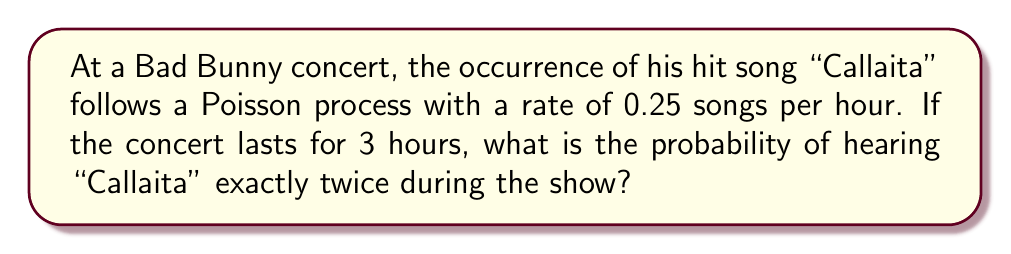Could you help me with this problem? Let's approach this step-by-step using the Poisson distribution:

1) The Poisson distribution is given by the formula:

   $$P(X = k) = \frac{e^{-\lambda} \lambda^k}{k!}$$

   where:
   - $\lambda$ is the average number of events in the interval
   - $k$ is the number of events we're interested in
   - $e$ is Euler's number (approximately 2.71828)

2) In this case:
   - The rate is 0.25 songs per hour
   - The concert lasts 3 hours
   - We want to know the probability of hearing the song exactly twice ($k = 2$)

3) First, calculate $\lambda$:
   $$\lambda = \text{rate} \times \text{time} = 0.25 \times 3 = 0.75$$

4) Now, let's plug these values into the Poisson formula:

   $$P(X = 2) = \frac{e^{-0.75} 0.75^2}{2!}$$

5) Simplify:
   $$P(X = 2) = \frac{e^{-0.75} \times 0.5625}{2}$$

6) Calculate:
   $$P(X = 2) \approx 0.1605$$

7) Convert to a percentage:
   $$0.1605 \times 100\% \approx 16.05\%$$

Therefore, the probability of hearing "Callaita" exactly twice during the 3-hour concert is approximately 16.05%.
Answer: 16.05% 